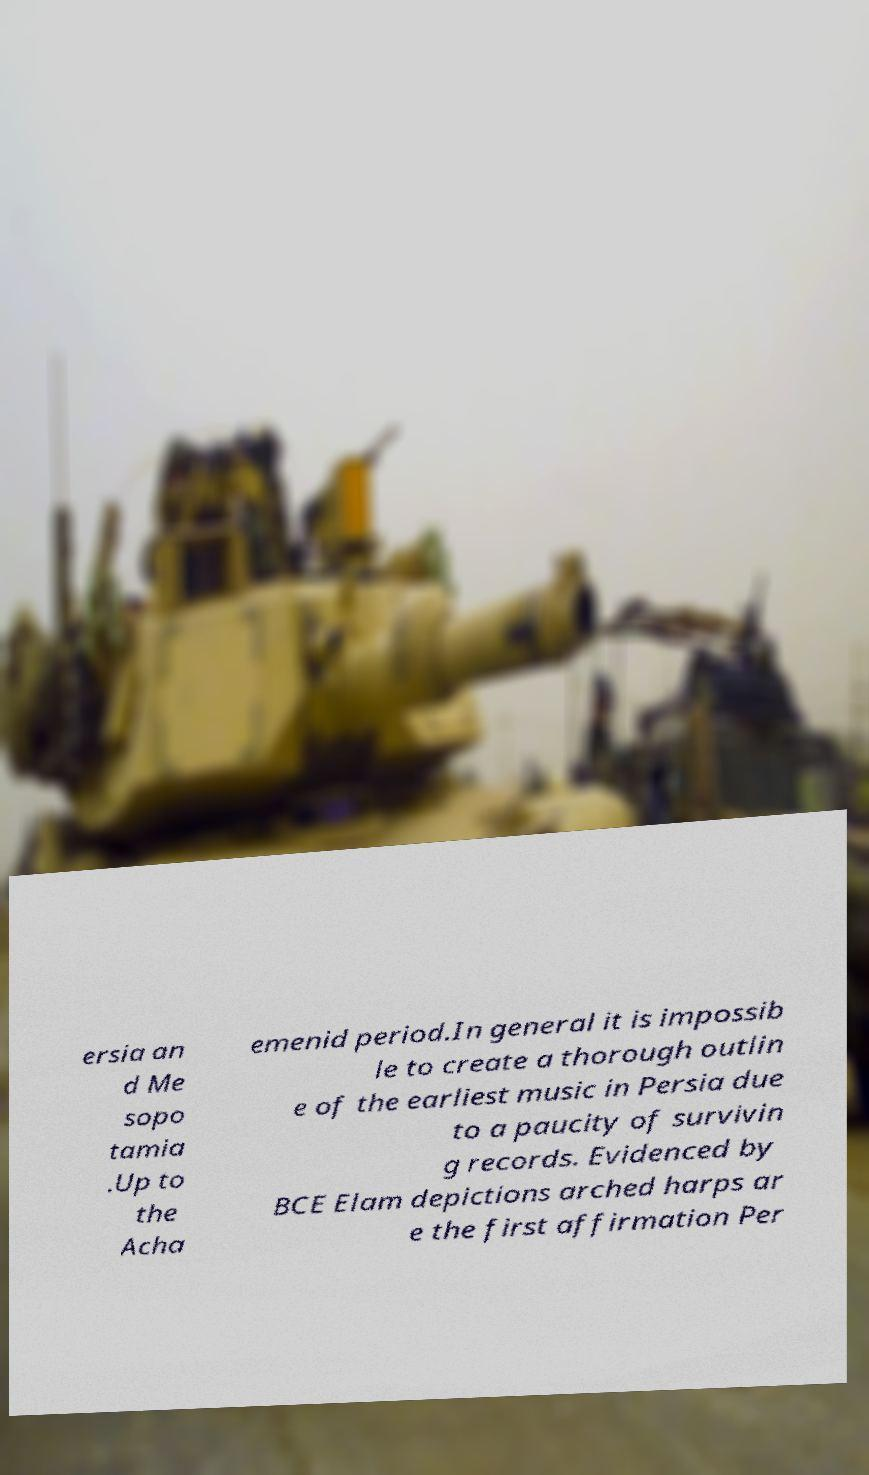Please identify and transcribe the text found in this image. ersia an d Me sopo tamia .Up to the Acha emenid period.In general it is impossib le to create a thorough outlin e of the earliest music in Persia due to a paucity of survivin g records. Evidenced by BCE Elam depictions arched harps ar e the first affirmation Per 